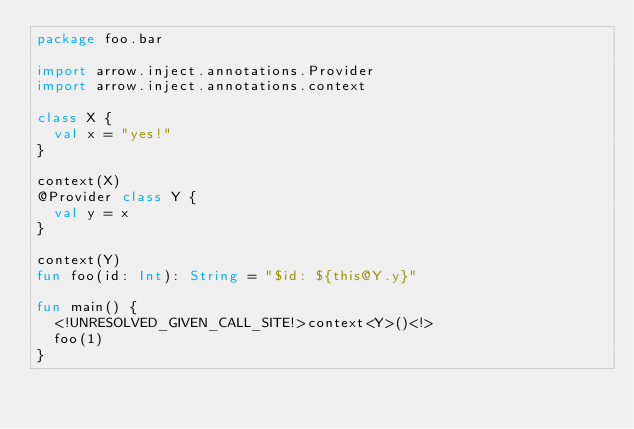<code> <loc_0><loc_0><loc_500><loc_500><_Kotlin_>package foo.bar

import arrow.inject.annotations.Provider
import arrow.inject.annotations.context

class X {
  val x = "yes!"
}

context(X)
@Provider class Y {
  val y = x
}

context(Y)
fun foo(id: Int): String = "$id: ${this@Y.y}"

fun main() {
  <!UNRESOLVED_GIVEN_CALL_SITE!>context<Y>()<!>
  foo(1)
}
</code> 